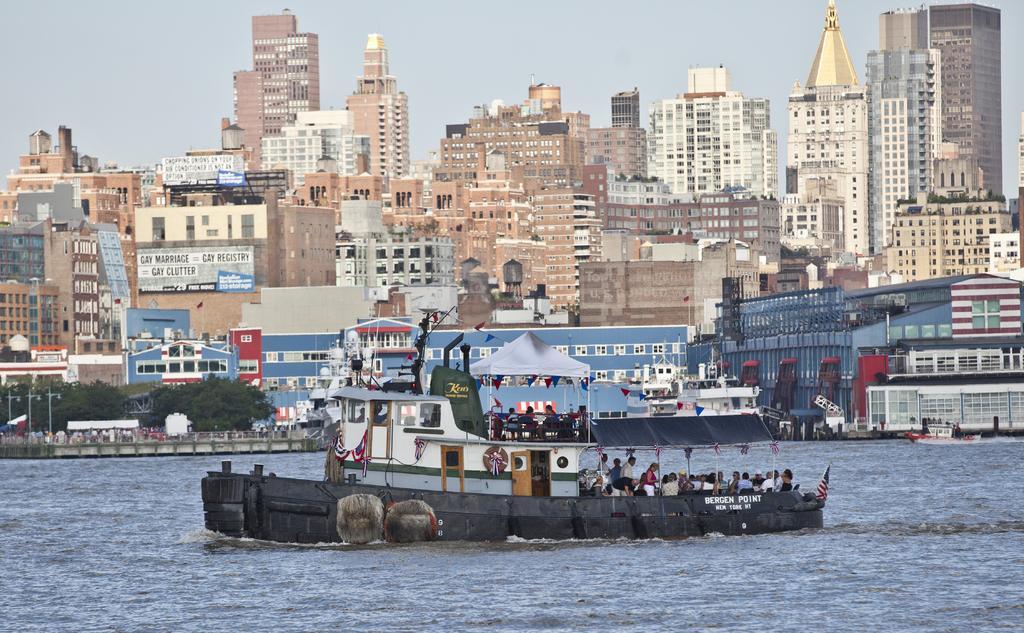How would you summarize this image in a sentence or two? In this picture there is a boat on the water and there are few people in the boat and there are few buildings and trees in the background. 